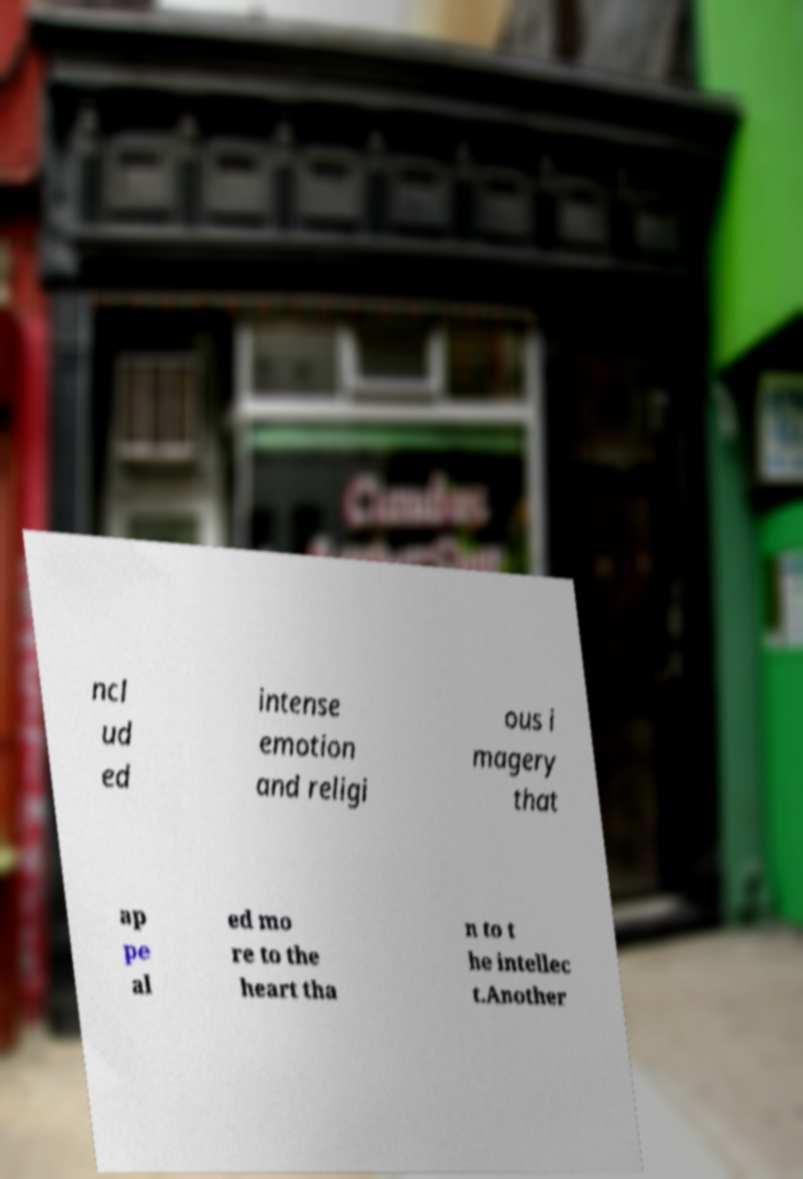Could you extract and type out the text from this image? ncl ud ed intense emotion and religi ous i magery that ap pe al ed mo re to the heart tha n to t he intellec t.Another 